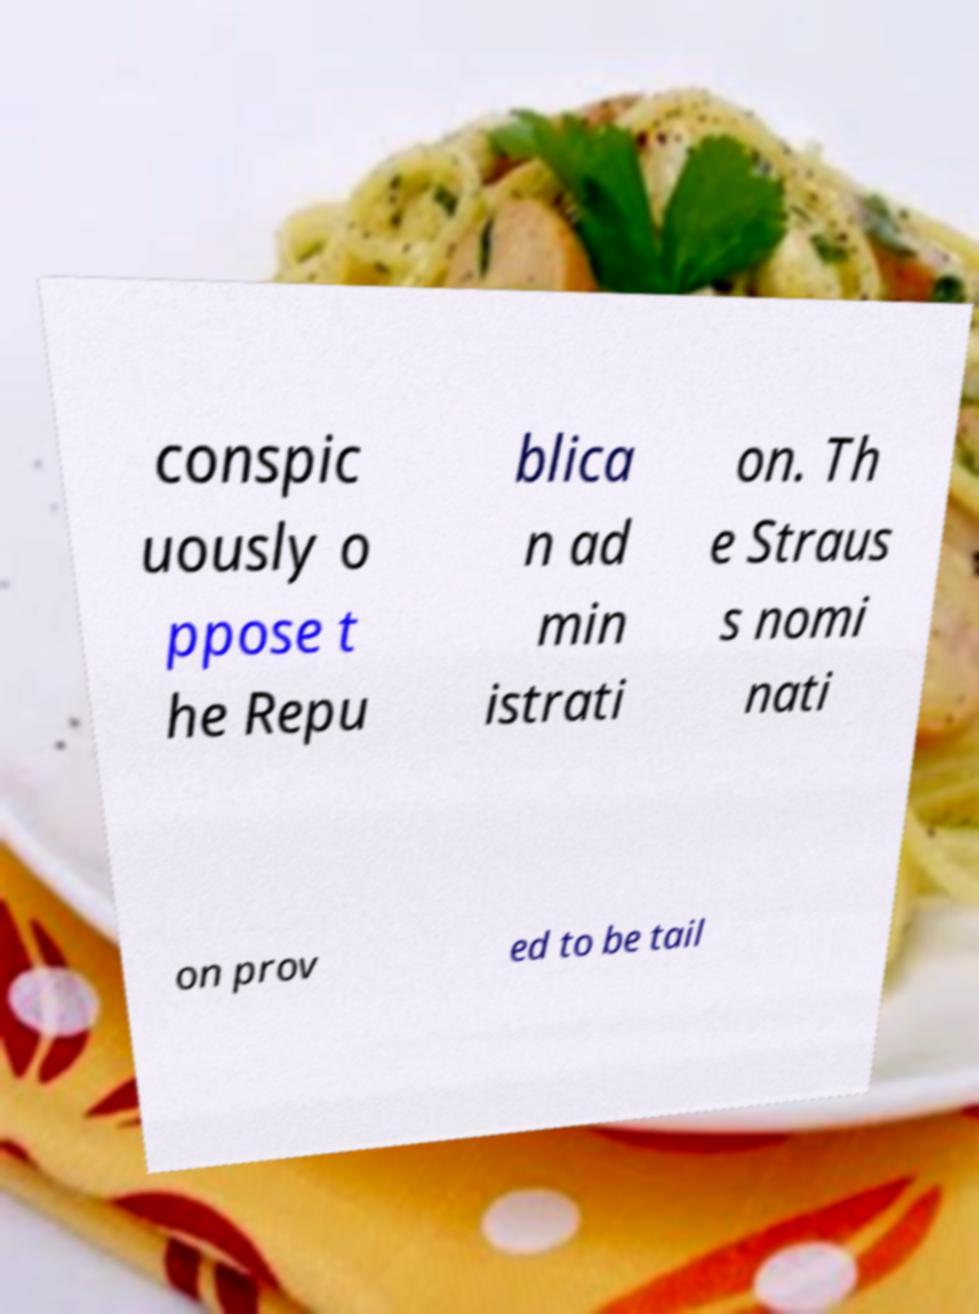Can you accurately transcribe the text from the provided image for me? conspic uously o ppose t he Repu blica n ad min istrati on. Th e Straus s nomi nati on prov ed to be tail 